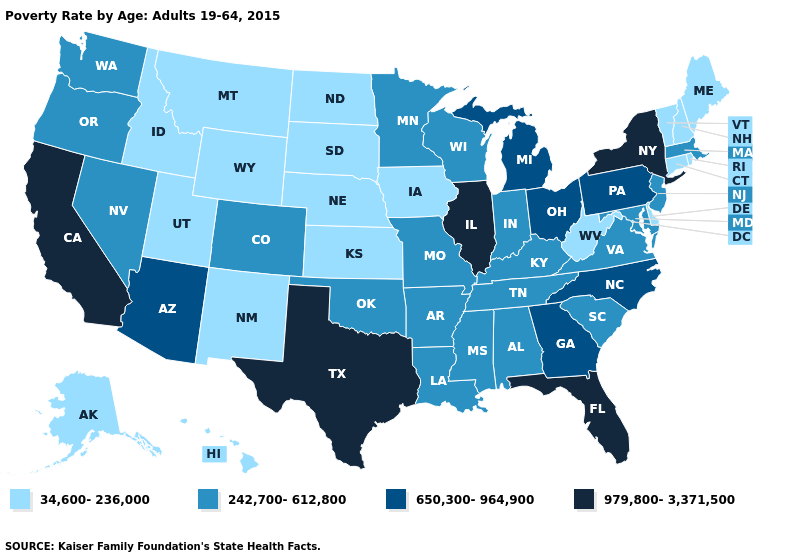Does the map have missing data?
Write a very short answer. No. What is the highest value in the South ?
Be succinct. 979,800-3,371,500. Name the states that have a value in the range 242,700-612,800?
Short answer required. Alabama, Arkansas, Colorado, Indiana, Kentucky, Louisiana, Maryland, Massachusetts, Minnesota, Mississippi, Missouri, Nevada, New Jersey, Oklahoma, Oregon, South Carolina, Tennessee, Virginia, Washington, Wisconsin. What is the lowest value in states that border Illinois?
Keep it brief. 34,600-236,000. What is the value of New Hampshire?
Be succinct. 34,600-236,000. Does Texas have the highest value in the South?
Keep it brief. Yes. What is the value of Florida?
Quick response, please. 979,800-3,371,500. How many symbols are there in the legend?
Give a very brief answer. 4. What is the value of Mississippi?
Be succinct. 242,700-612,800. Name the states that have a value in the range 34,600-236,000?
Be succinct. Alaska, Connecticut, Delaware, Hawaii, Idaho, Iowa, Kansas, Maine, Montana, Nebraska, New Hampshire, New Mexico, North Dakota, Rhode Island, South Dakota, Utah, Vermont, West Virginia, Wyoming. Does Connecticut have the lowest value in the USA?
Write a very short answer. Yes. Name the states that have a value in the range 242,700-612,800?
Write a very short answer. Alabama, Arkansas, Colorado, Indiana, Kentucky, Louisiana, Maryland, Massachusetts, Minnesota, Mississippi, Missouri, Nevada, New Jersey, Oklahoma, Oregon, South Carolina, Tennessee, Virginia, Washington, Wisconsin. Name the states that have a value in the range 242,700-612,800?
Be succinct. Alabama, Arkansas, Colorado, Indiana, Kentucky, Louisiana, Maryland, Massachusetts, Minnesota, Mississippi, Missouri, Nevada, New Jersey, Oklahoma, Oregon, South Carolina, Tennessee, Virginia, Washington, Wisconsin. Name the states that have a value in the range 979,800-3,371,500?
Answer briefly. California, Florida, Illinois, New York, Texas. 